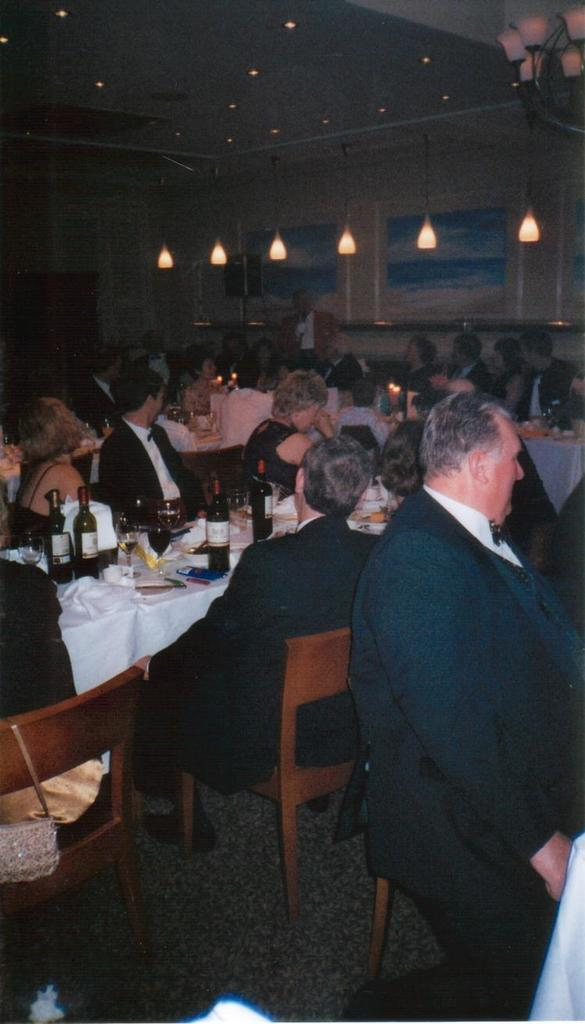What are the majority of people in the room doing? Most of the persons in the room are sitting on chairs. What can be seen on the wall in the room? There is a poster on the wall. Where are the lights located in the room? Lights are attached to the roof top. What items can be found on the tables in the room? There are bottles and glasses on the tables. What type of paste is being used by the parent in the image? There is no parent or paste present in the image. How does the transport system function in the room? There is no transport system present in the room; it is an indoor setting. 